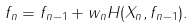<formula> <loc_0><loc_0><loc_500><loc_500>f _ { n } = f _ { n - 1 } + w _ { n } H ( X _ { n } , f _ { n - 1 } ) .</formula> 